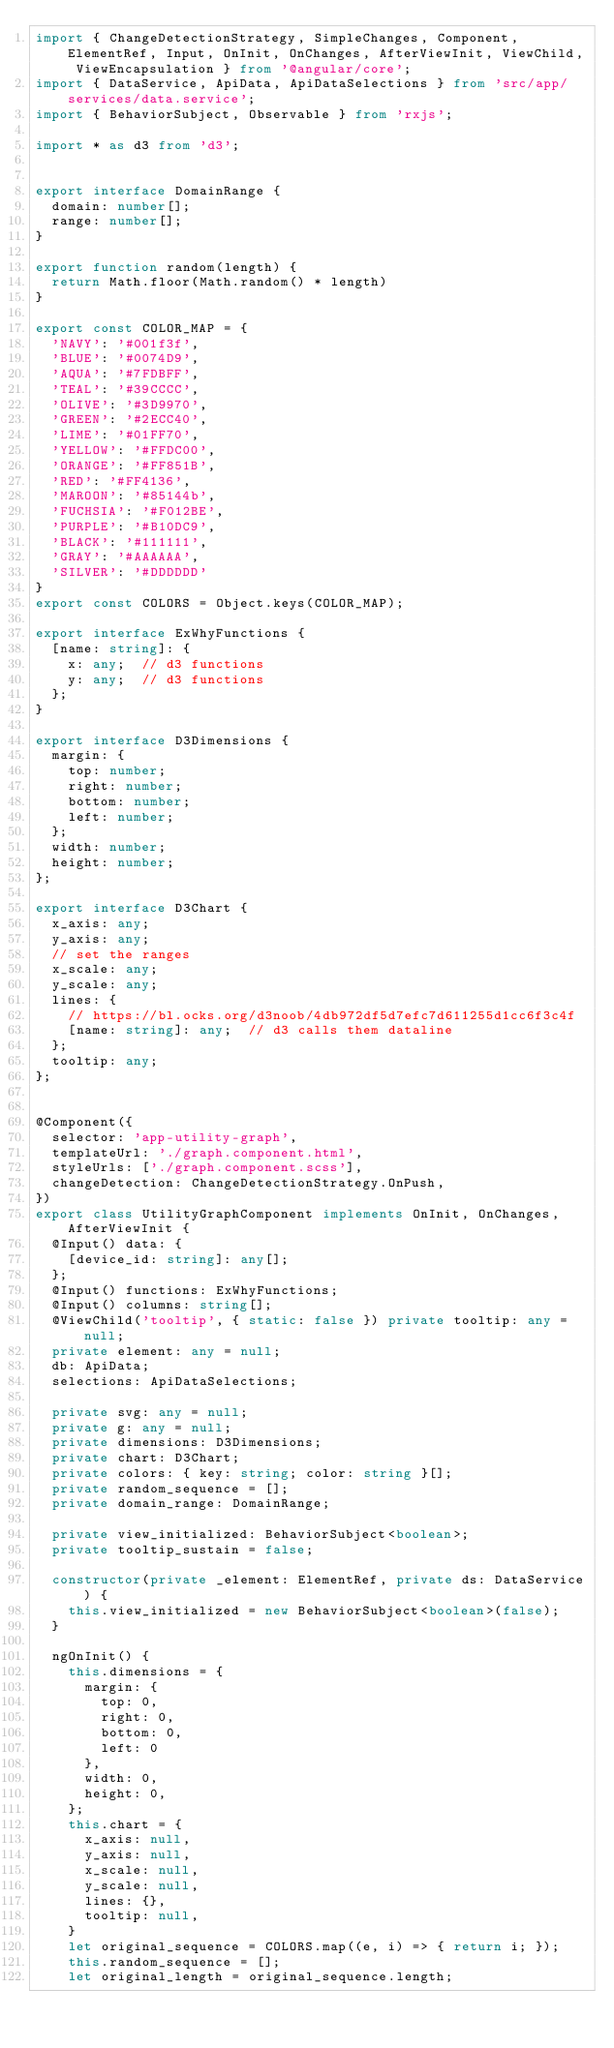Convert code to text. <code><loc_0><loc_0><loc_500><loc_500><_TypeScript_>import { ChangeDetectionStrategy, SimpleChanges, Component, ElementRef, Input, OnInit, OnChanges, AfterViewInit, ViewChild, ViewEncapsulation } from '@angular/core';
import { DataService, ApiData, ApiDataSelections } from 'src/app/services/data.service';
import { BehaviorSubject, Observable } from 'rxjs';

import * as d3 from 'd3';


export interface DomainRange {
  domain: number[];
  range: number[];
}

export function random(length) {
  return Math.floor(Math.random() * length)
}

export const COLOR_MAP = {
  'NAVY': '#001f3f',
  'BLUE': '#0074D9',
  'AQUA': '#7FDBFF',
  'TEAL': '#39CCCC',
  'OLIVE': '#3D9970',
  'GREEN': '#2ECC40',
  'LIME': '#01FF70',
  'YELLOW': '#FFDC00',
  'ORANGE': '#FF851B',
  'RED': '#FF4136',
  'MAROON': '#85144b',
  'FUCHSIA': '#F012BE',
  'PURPLE': '#B10DC9',
  'BLACK': '#111111',
  'GRAY': '#AAAAAA',
  'SILVER': '#DDDDDD'
}
export const COLORS = Object.keys(COLOR_MAP);

export interface ExWhyFunctions {
  [name: string]: {
    x: any;  // d3 functions
    y: any;  // d3 functions
  };
}

export interface D3Dimensions {
  margin: {
    top: number;
    right: number;
    bottom: number;
    left: number;
  };
  width: number;
  height: number;
};

export interface D3Chart {
  x_axis: any;
  y_axis: any;
  // set the ranges
  x_scale: any;
  y_scale: any;
  lines: {
    // https://bl.ocks.org/d3noob/4db972df5d7efc7d611255d1cc6f3c4f
    [name: string]: any;  // d3 calls them dataline
  };
  tooltip: any;
};


@Component({
  selector: 'app-utility-graph',
  templateUrl: './graph.component.html',
  styleUrls: ['./graph.component.scss'],
  changeDetection: ChangeDetectionStrategy.OnPush,
})
export class UtilityGraphComponent implements OnInit, OnChanges, AfterViewInit {
  @Input() data: {
    [device_id: string]: any[];
  };
  @Input() functions: ExWhyFunctions;
  @Input() columns: string[];
  @ViewChild('tooltip', { static: false }) private tooltip: any = null;
  private element: any = null;
  db: ApiData;
  selections: ApiDataSelections;

  private svg: any = null;
  private g: any = null;
  private dimensions: D3Dimensions;
  private chart: D3Chart;
  private colors: { key: string; color: string }[];
  private random_sequence = [];
  private domain_range: DomainRange;

  private view_initialized: BehaviorSubject<boolean>;
  private tooltip_sustain = false;

  constructor(private _element: ElementRef, private ds: DataService) {
    this.view_initialized = new BehaviorSubject<boolean>(false);
  }

  ngOnInit() {
    this.dimensions = {
      margin: {
        top: 0,
        right: 0,
        bottom: 0,
        left: 0
      },
      width: 0,
      height: 0,
    };
    this.chart = {
      x_axis: null,
      y_axis: null,
      x_scale: null,
      y_scale: null,
      lines: {},
      tooltip: null,
    }
    let original_sequence = COLORS.map((e, i) => { return i; });
    this.random_sequence = [];
    let original_length = original_sequence.length;</code> 